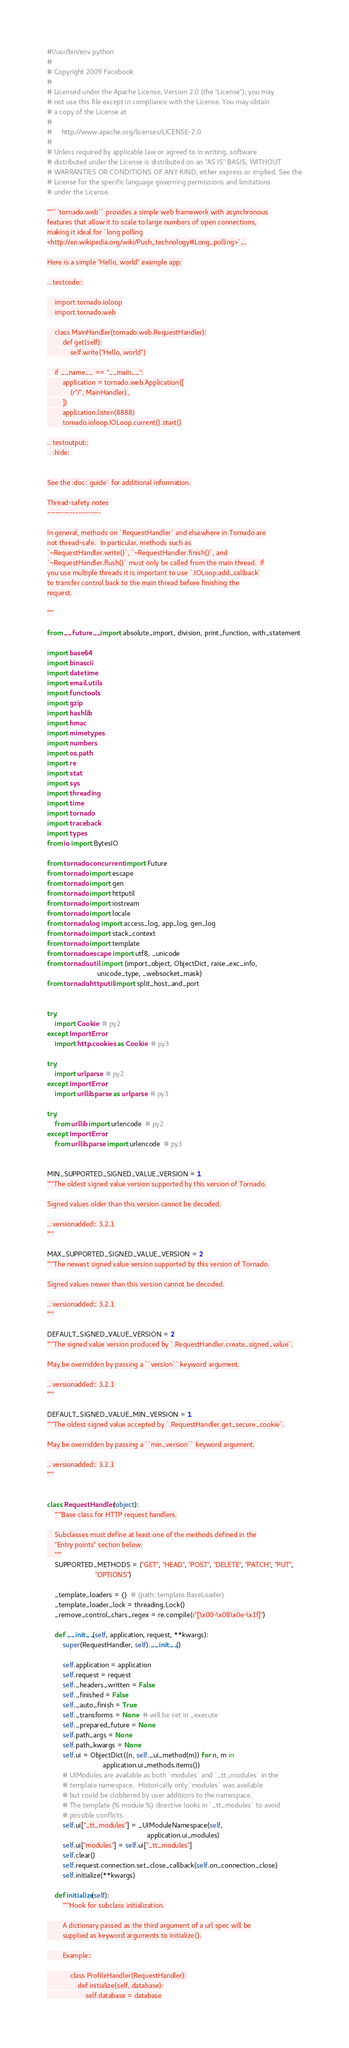<code> <loc_0><loc_0><loc_500><loc_500><_Python_>#!/usr/bin/env python
#
# Copyright 2009 Facebook
#
# Licensed under the Apache License, Version 2.0 (the "License"); you may
# not use this file except in compliance with the License. You may obtain
# a copy of the License at
#
#     http://www.apache.org/licenses/LICENSE-2.0
#
# Unless required by applicable law or agreed to in writing, software
# distributed under the License is distributed on an "AS IS" BASIS, WITHOUT
# WARRANTIES OR CONDITIONS OF ANY KIND, either express or implied. See the
# License for the specific language governing permissions and limitations
# under the License.

"""``tornado.web`` provides a simple web framework with asynchronous
features that allow it to scale to large numbers of open connections,
making it ideal for `long polling
<http://en.wikipedia.org/wiki/Push_technology#Long_polling>`_.

Here is a simple "Hello, world" example app:

.. testcode::

    import tornado.ioloop
    import tornado.web

    class MainHandler(tornado.web.RequestHandler):
        def get(self):
            self.write("Hello, world")

    if __name__ == "__main__":
        application = tornado.web.Application([
            (r"/", MainHandler),
        ])
        application.listen(8888)
        tornado.ioloop.IOLoop.current().start()

.. testoutput::
   :hide:


See the :doc:`guide` for additional information.

Thread-safety notes
-------------------

In general, methods on `RequestHandler` and elsewhere in Tornado are
not thread-safe.  In particular, methods such as
`~RequestHandler.write()`, `~RequestHandler.finish()`, and
`~RequestHandler.flush()` must only be called from the main thread.  If
you use multiple threads it is important to use `.IOLoop.add_callback`
to transfer control back to the main thread before finishing the
request.

"""

from __future__ import absolute_import, division, print_function, with_statement

import base64
import binascii
import datetime
import email.utils
import functools
import gzip
import hashlib
import hmac
import mimetypes
import numbers
import os.path
import re
import stat
import sys
import threading
import time
import tornado
import traceback
import types
from io import BytesIO

from tornado.concurrent import Future
from tornado import escape
from tornado import gen
from tornado import httputil
from tornado import iostream
from tornado import locale
from tornado.log import access_log, app_log, gen_log
from tornado import stack_context
from tornado import template
from tornado.escape import utf8, _unicode
from tornado.util import (import_object, ObjectDict, raise_exc_info,
                          unicode_type, _websocket_mask)
from tornado.httputil import split_host_and_port


try:
    import Cookie  # py2
except ImportError:
    import http.cookies as Cookie  # py3

try:
    import urlparse  # py2
except ImportError:
    import urllib.parse as urlparse  # py3

try:
    from urllib import urlencode  # py2
except ImportError:
    from urllib.parse import urlencode  # py3


MIN_SUPPORTED_SIGNED_VALUE_VERSION = 1
"""The oldest signed value version supported by this version of Tornado.

Signed values older than this version cannot be decoded.

.. versionadded:: 3.2.1
"""

MAX_SUPPORTED_SIGNED_VALUE_VERSION = 2
"""The newest signed value version supported by this version of Tornado.

Signed values newer than this version cannot be decoded.

.. versionadded:: 3.2.1
"""

DEFAULT_SIGNED_VALUE_VERSION = 2
"""The signed value version produced by `.RequestHandler.create_signed_value`.

May be overridden by passing a ``version`` keyword argument.

.. versionadded:: 3.2.1
"""

DEFAULT_SIGNED_VALUE_MIN_VERSION = 1
"""The oldest signed value accepted by `.RequestHandler.get_secure_cookie`.

May be overridden by passing a ``min_version`` keyword argument.

.. versionadded:: 3.2.1
"""


class RequestHandler(object):
    """Base class for HTTP request handlers.

    Subclasses must define at least one of the methods defined in the
    "Entry points" section below.
    """
    SUPPORTED_METHODS = ("GET", "HEAD", "POST", "DELETE", "PATCH", "PUT",
                         "OPTIONS")

    _template_loaders = {}  # {path: template.BaseLoader}
    _template_loader_lock = threading.Lock()
    _remove_control_chars_regex = re.compile(r"[\x00-\x08\x0e-\x1f]")

    def __init__(self, application, request, **kwargs):
        super(RequestHandler, self).__init__()

        self.application = application
        self.request = request
        self._headers_written = False
        self._finished = False
        self._auto_finish = True
        self._transforms = None  # will be set in _execute
        self._prepared_future = None
        self.path_args = None
        self.path_kwargs = None
        self.ui = ObjectDict((n, self._ui_method(m)) for n, m in
                             application.ui_methods.items())
        # UIModules are available as both `modules` and `_tt_modules` in the
        # template namespace.  Historically only `modules` was available
        # but could be clobbered by user additions to the namespace.
        # The template {% module %} directive looks in `_tt_modules` to avoid
        # possible conflicts.
        self.ui["_tt_modules"] = _UIModuleNamespace(self,
                                                    application.ui_modules)
        self.ui["modules"] = self.ui["_tt_modules"]
        self.clear()
        self.request.connection.set_close_callback(self.on_connection_close)
        self.initialize(**kwargs)

    def initialize(self):
        """Hook for subclass initialization.

        A dictionary passed as the third argument of a url spec will be
        supplied as keyword arguments to initialize().

        Example::

            class ProfileHandler(RequestHandler):
                def initialize(self, database):
                    self.database = database
</code> 